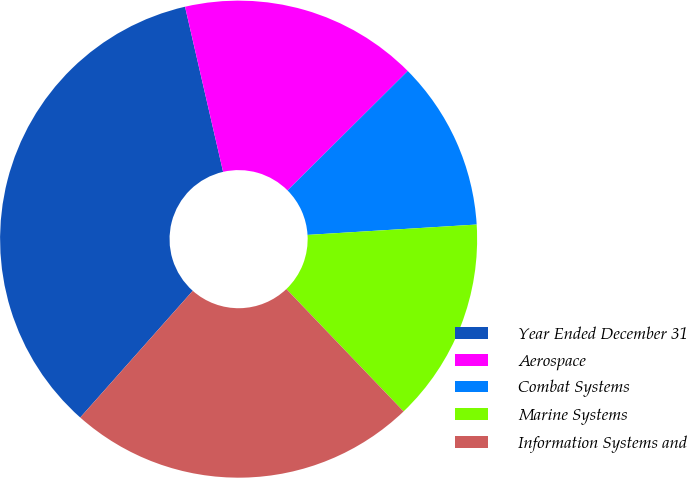Convert chart to OTSL. <chart><loc_0><loc_0><loc_500><loc_500><pie_chart><fcel>Year Ended December 31<fcel>Aerospace<fcel>Combat Systems<fcel>Marine Systems<fcel>Information Systems and<nl><fcel>34.84%<fcel>16.15%<fcel>11.48%<fcel>13.82%<fcel>23.71%<nl></chart> 